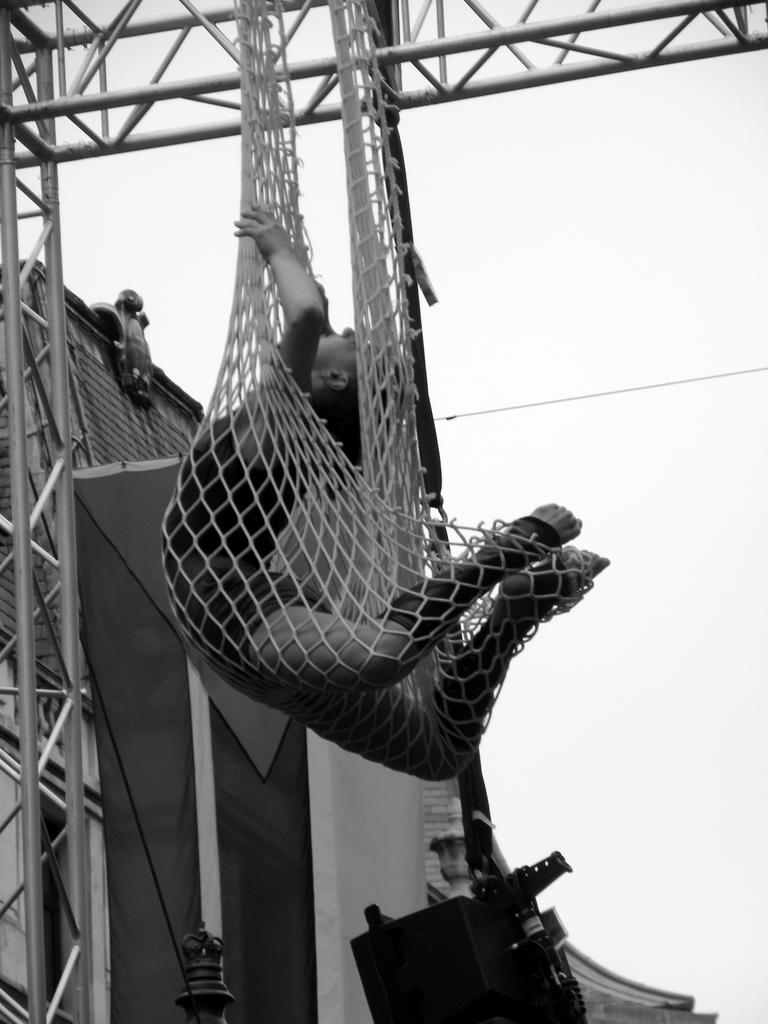What is happening to the person in the image? The person is trapped in a net in the image. How is the net positioned in the image? The net is hanging over an iron frame. What type of structure can be seen in the background of the image? There is a house visible in the image. What type of rifle is the squirrel holding in the image? There is no squirrel or rifle present in the image. 